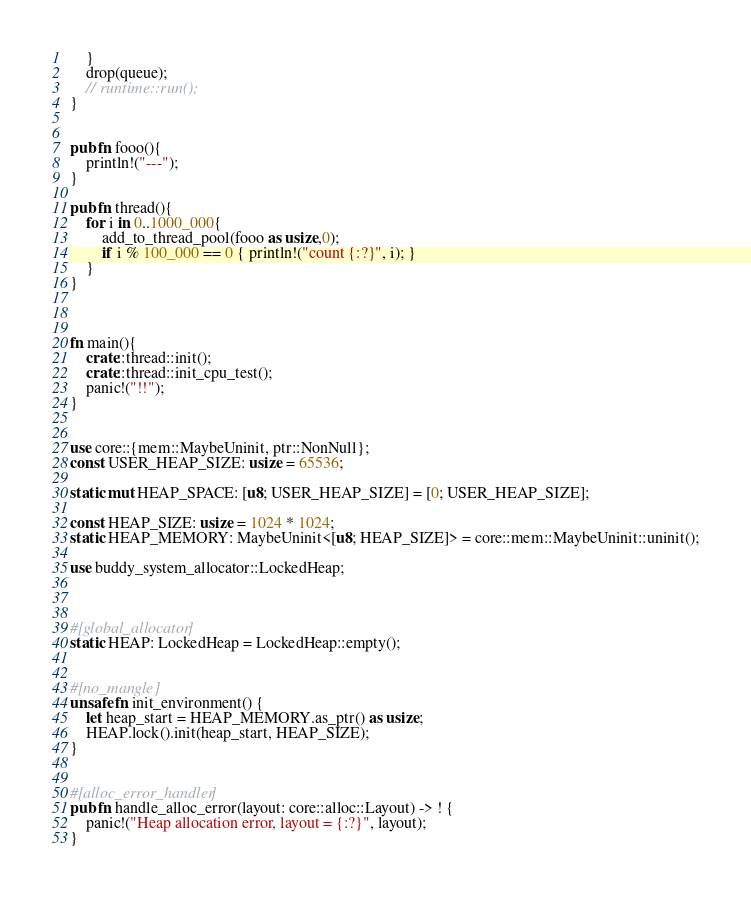Convert code to text. <code><loc_0><loc_0><loc_500><loc_500><_Rust_>    }
    drop(queue);
    // runtime::run();
}


pub fn fooo(){
    println!("---");
}

pub fn thread(){
    for i in 0..1000_000{
        add_to_thread_pool(fooo as usize,0);
        if i % 100_000 == 0 { println!("count {:?}", i); }
    }
}



fn main(){
    crate::thread::init();
    crate::thread::init_cpu_test();
    panic!("!!");
}


use core::{mem::MaybeUninit, ptr::NonNull};
const USER_HEAP_SIZE: usize = 65536;

static mut HEAP_SPACE: [u8; USER_HEAP_SIZE] = [0; USER_HEAP_SIZE];

const HEAP_SIZE: usize = 1024 * 1024;
static HEAP_MEMORY: MaybeUninit<[u8; HEAP_SIZE]> = core::mem::MaybeUninit::uninit();

use buddy_system_allocator::LockedHeap;



#[global_allocator]
static HEAP: LockedHeap = LockedHeap::empty();


#[no_mangle]
unsafe fn init_environment() {
    let heap_start = HEAP_MEMORY.as_ptr() as usize;
    HEAP.lock().init(heap_start, HEAP_SIZE);
}


#[alloc_error_handler]
pub fn handle_alloc_error(layout: core::alloc::Layout) -> ! {
    panic!("Heap allocation error, layout = {:?}", layout);
}
</code> 